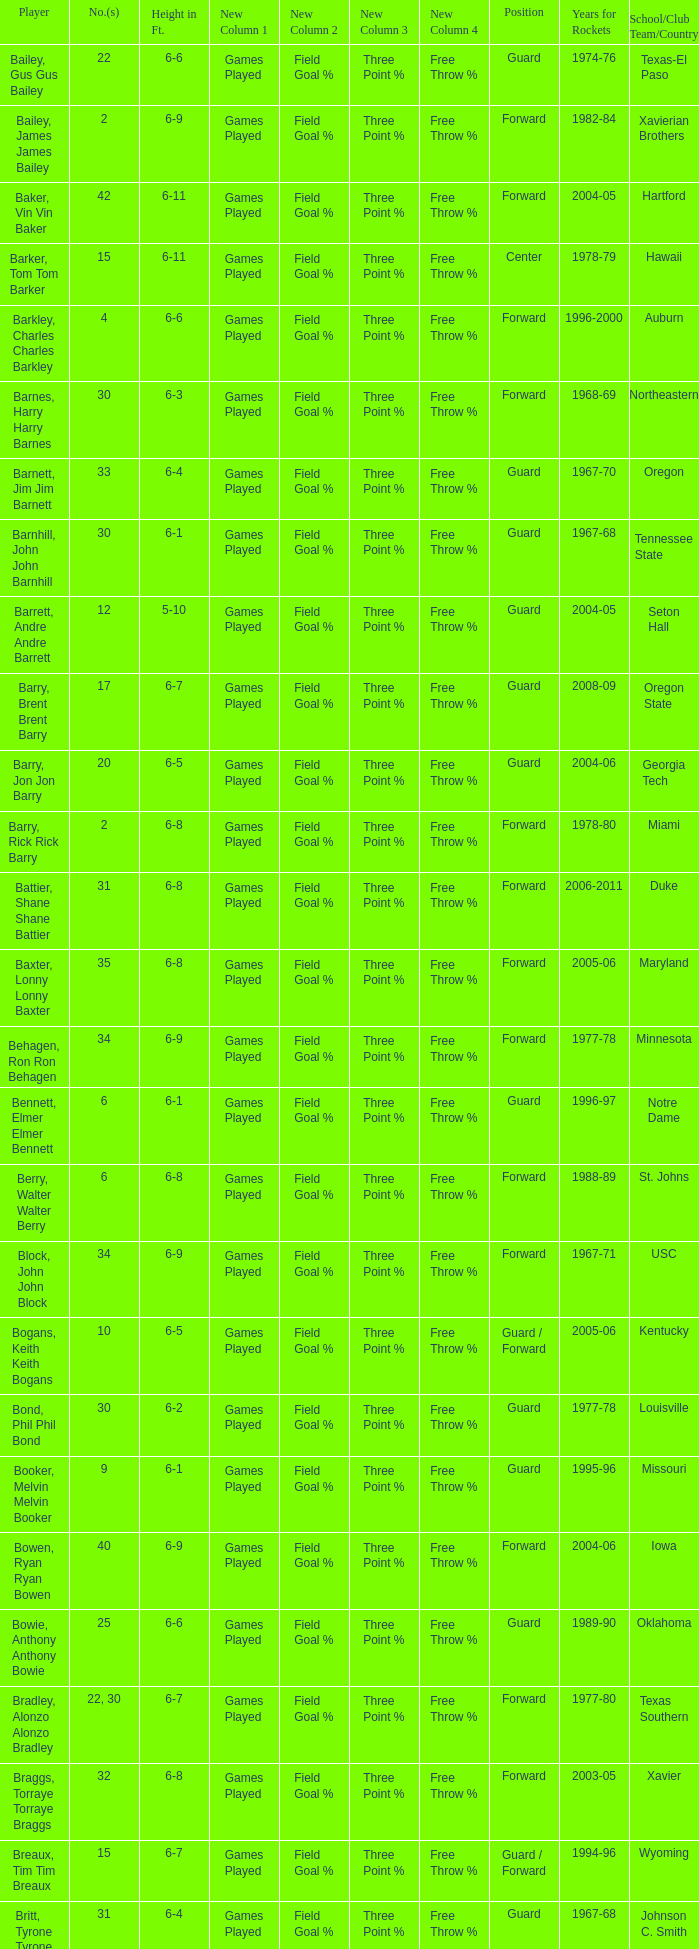What years did the player from LaSalle play for the Rockets? 1982-83. 